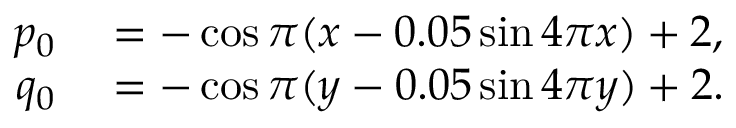Convert formula to latex. <formula><loc_0><loc_0><loc_500><loc_500>\begin{array} { r l } { p _ { 0 } } & = - \cos \pi ( x - 0 . 0 5 \sin 4 \pi x ) + 2 , } \\ { q _ { 0 } } & = - \cos \pi ( y - 0 . 0 5 \sin 4 \pi y ) + 2 . } \end{array}</formula> 